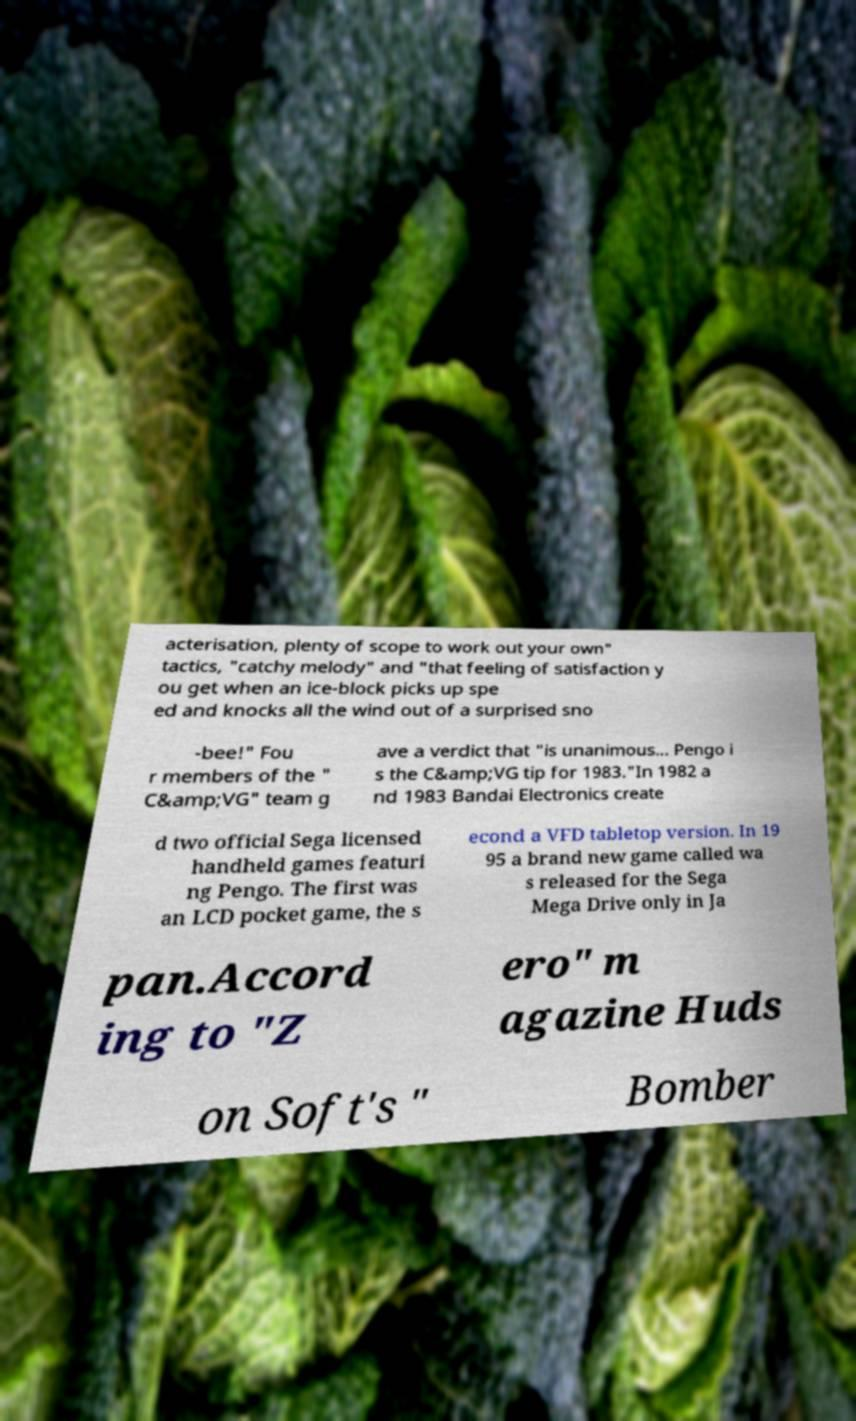I need the written content from this picture converted into text. Can you do that? acterisation, plenty of scope to work out your own" tactics, "catchy melody" and "that feeling of satisfaction y ou get when an ice-block picks up spe ed and knocks all the wind out of a surprised sno -bee!" Fou r members of the " C&amp;VG" team g ave a verdict that "is unanimous... Pengo i s the C&amp;VG tip for 1983."In 1982 a nd 1983 Bandai Electronics create d two official Sega licensed handheld games featuri ng Pengo. The first was an LCD pocket game, the s econd a VFD tabletop version. In 19 95 a brand new game called wa s released for the Sega Mega Drive only in Ja pan.Accord ing to "Z ero" m agazine Huds on Soft's " Bomber 